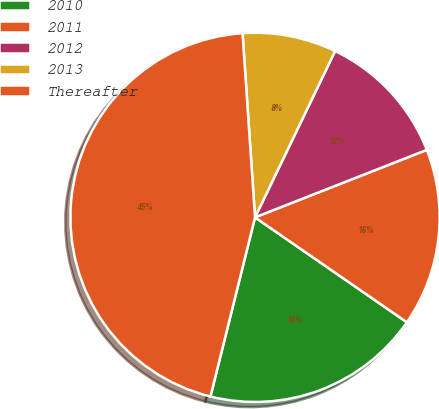Convert chart to OTSL. <chart><loc_0><loc_0><loc_500><loc_500><pie_chart><fcel>2010<fcel>2011<fcel>2012<fcel>2013<fcel>Thereafter<nl><fcel>19.26%<fcel>15.58%<fcel>11.9%<fcel>8.22%<fcel>45.04%<nl></chart> 